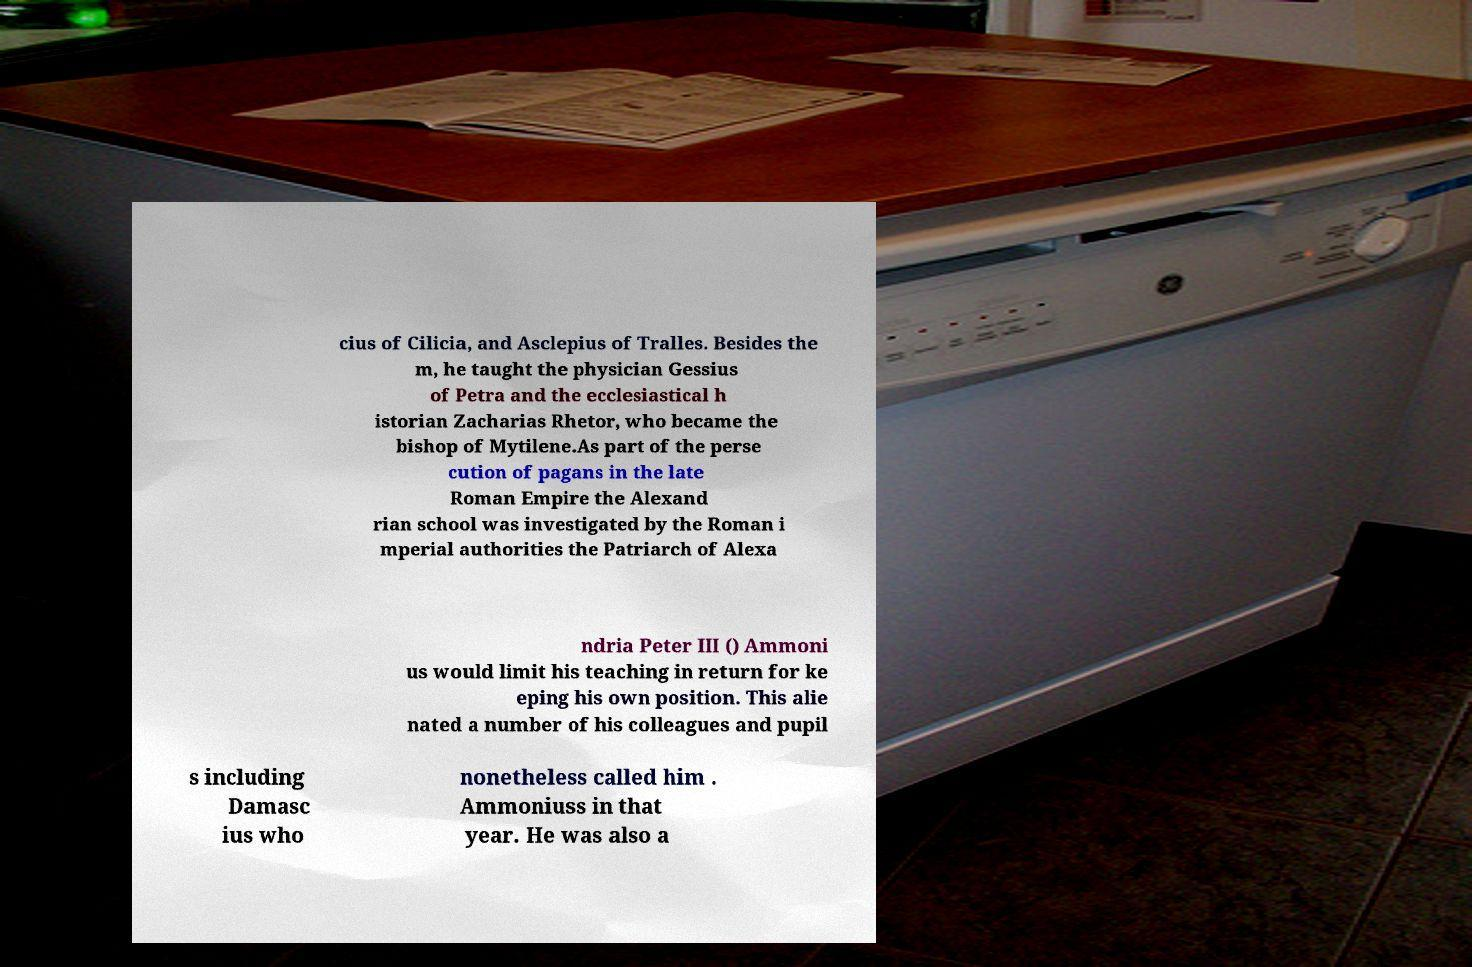Can you read and provide the text displayed in the image?This photo seems to have some interesting text. Can you extract and type it out for me? cius of Cilicia, and Asclepius of Tralles. Besides the m, he taught the physician Gessius of Petra and the ecclesiastical h istorian Zacharias Rhetor, who became the bishop of Mytilene.As part of the perse cution of pagans in the late Roman Empire the Alexand rian school was investigated by the Roman i mperial authorities the Patriarch of Alexa ndria Peter III () Ammoni us would limit his teaching in return for ke eping his own position. This alie nated a number of his colleagues and pupil s including Damasc ius who nonetheless called him . Ammoniuss in that year. He was also a 